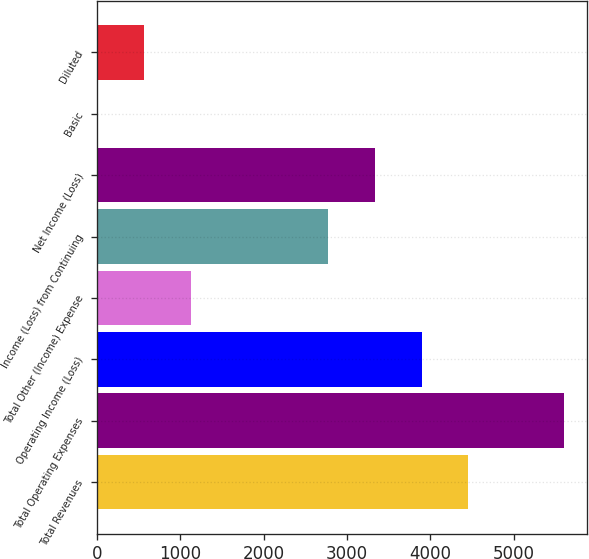Convert chart to OTSL. <chart><loc_0><loc_0><loc_500><loc_500><bar_chart><fcel>Total Revenues<fcel>Total Operating Expenses<fcel>Operating Income (Loss)<fcel>Total Other (Income) Expense<fcel>Income (Loss) from Continuing<fcel>Net Income (Loss)<fcel>Basic<fcel>Diluted<nl><fcel>4458.56<fcel>5605<fcel>3898.67<fcel>1125.85<fcel>2778.89<fcel>3338.78<fcel>6.07<fcel>565.96<nl></chart> 